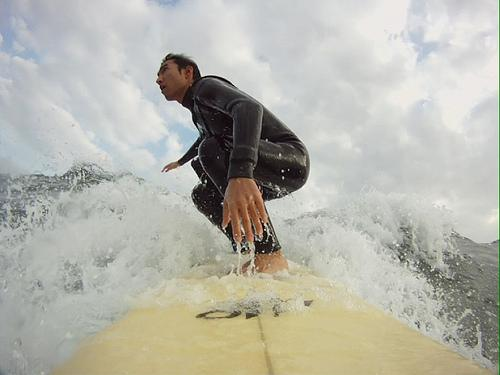What type of hairstyle does the man in the image have? The man has short black hair. What is the main activity happening in the image? A man is surfing on a large ocean wave. Identify the color of the wetsuit the man in the image is wearing. The man is wearing a black wetsuit. Determine the approximate number of visible splashes of water around the man. There are around 8 water splashes visible around the man. How would you describe the size and condition of the waves in the image? The waves are large, white, and grey, with a lot of foam and turbulence. Explain the weather conditions in the image based on the sky. The sky appears to have fluffy white clouds, suggesting a partly cloudy day. Evaluate this image's sentiment: positive, negative, or neutral? The image has a positive sentiment, as it shows a man enjoying surfing. What is the primary object the man is riding on in the image? The man is riding on a yellow surfboard with black lettering. In the image, where is the man looking? The man is looking out at the sea, towards the left. Read what is written on the surfboard. Unable to read the specific text Is there any anomaly in the picture? No Determine whether the man is standing or crouching on the surfboard. Crouching What is the surfer's hair color? Dark colored What type of physical activity is the man engaged in? Surfing Describe the main action happening in the image. A man is riding a surfboard on a wave. Select the correct description of the image from the following choices: a) A person skiing on a mountain, b) A man surfing a giant wave, c) A group of people relaxing on a beach. b) A man surfing a giant wave Identify the interaction between the man and the surfboard. The man is riding the surfboard. How is the quality of the image? Good What is the position of the man's right hand? Above the water What type of water body is seen in the image? Ocean Find the coordinates and dimensions of the man's left hand. X:219 Y:178 Width:47 Height:47 Detect any text on the surfboard. Black lettering Describe the sky in the image. Cloudy sky Identify the color of the man's wetsuit. Black List the colors of the surfboard. Yellow and white with black text State the type of weather depicted in the image. Cloudy Estimate the height of the wave the man is surfing. High State the overall sentiment or emotion derived from the image. Thrilling Locate the black wet suit worn by the man. X:179 Y:73 Width:132 Height:132 